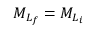<formula> <loc_0><loc_0><loc_500><loc_500>{ M } _ { { L } _ { f } } = { M } _ { { L } _ { i } }</formula> 